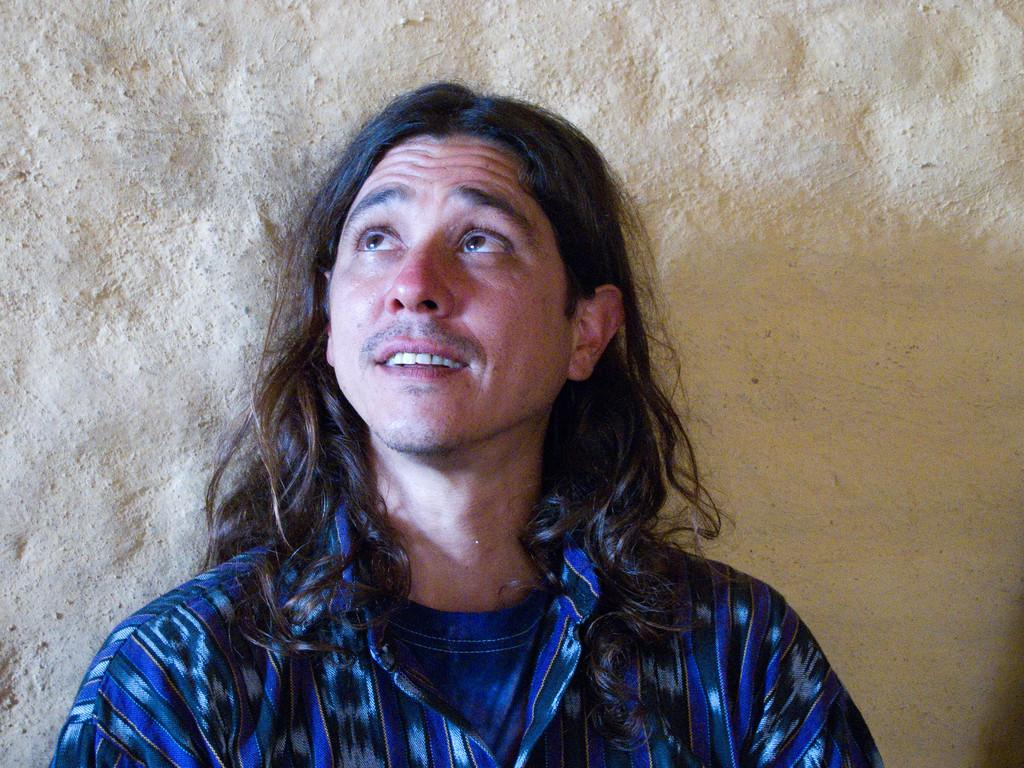Who or what is the main subject in the image? There is a person in the image. Can you describe the person's position in relation to the image? The person is in front. What can be seen behind the person? There is a wall behind the person. What type of roof can be seen above the person in the image? There is no roof visible in the image; only a wall is present behind the person. 